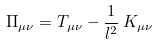<formula> <loc_0><loc_0><loc_500><loc_500>\Pi _ { \mu \nu } = T _ { \mu \nu } - \frac { 1 } { l ^ { 2 } } \, { K } _ { \mu \nu }</formula> 